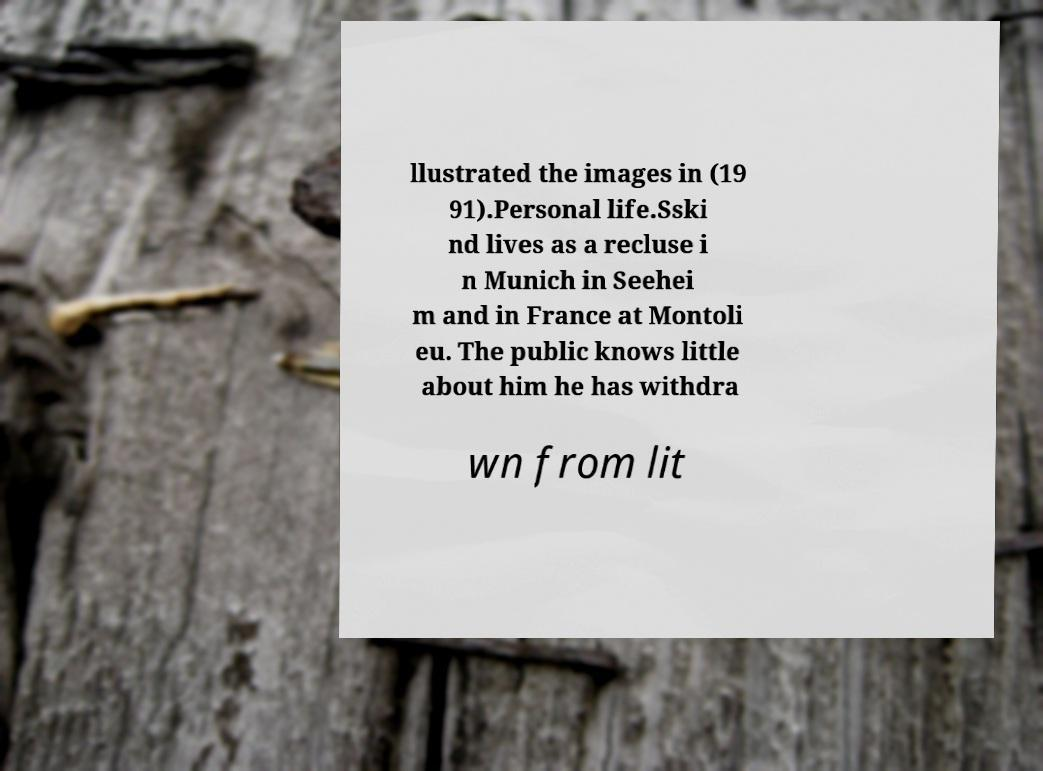Can you accurately transcribe the text from the provided image for me? llustrated the images in (19 91).Personal life.Sski nd lives as a recluse i n Munich in Seehei m and in France at Montoli eu. The public knows little about him he has withdra wn from lit 